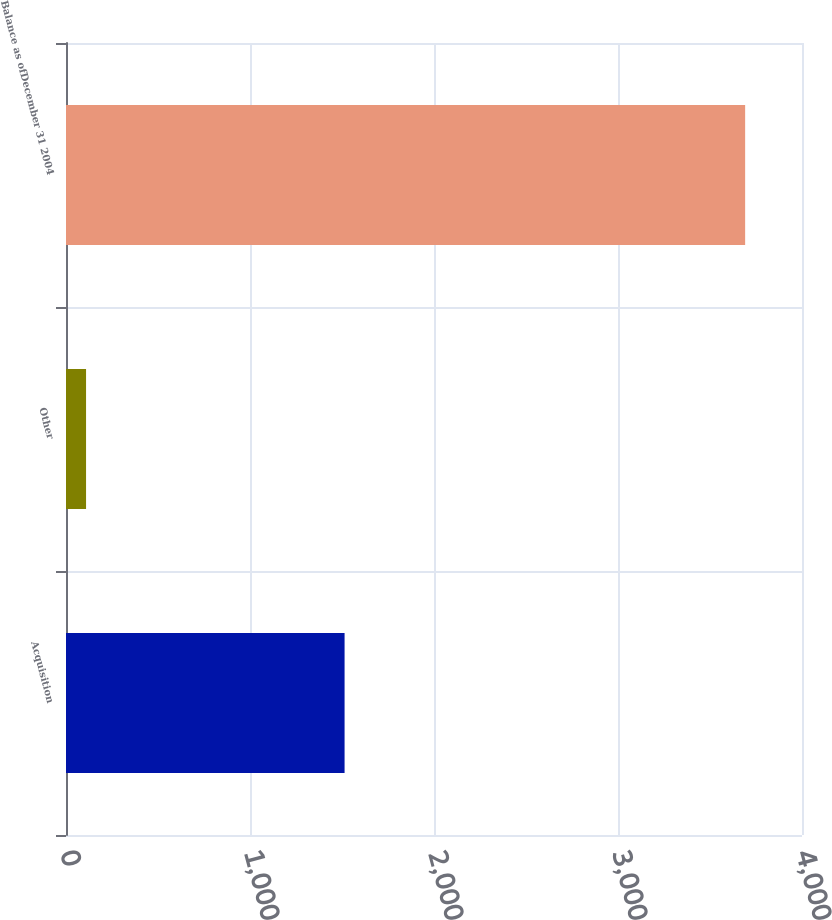Convert chart to OTSL. <chart><loc_0><loc_0><loc_500><loc_500><bar_chart><fcel>Acquisition<fcel>Other<fcel>Balance as ofDecember 31 2004<nl><fcel>1514<fcel>109<fcel>3691<nl></chart> 